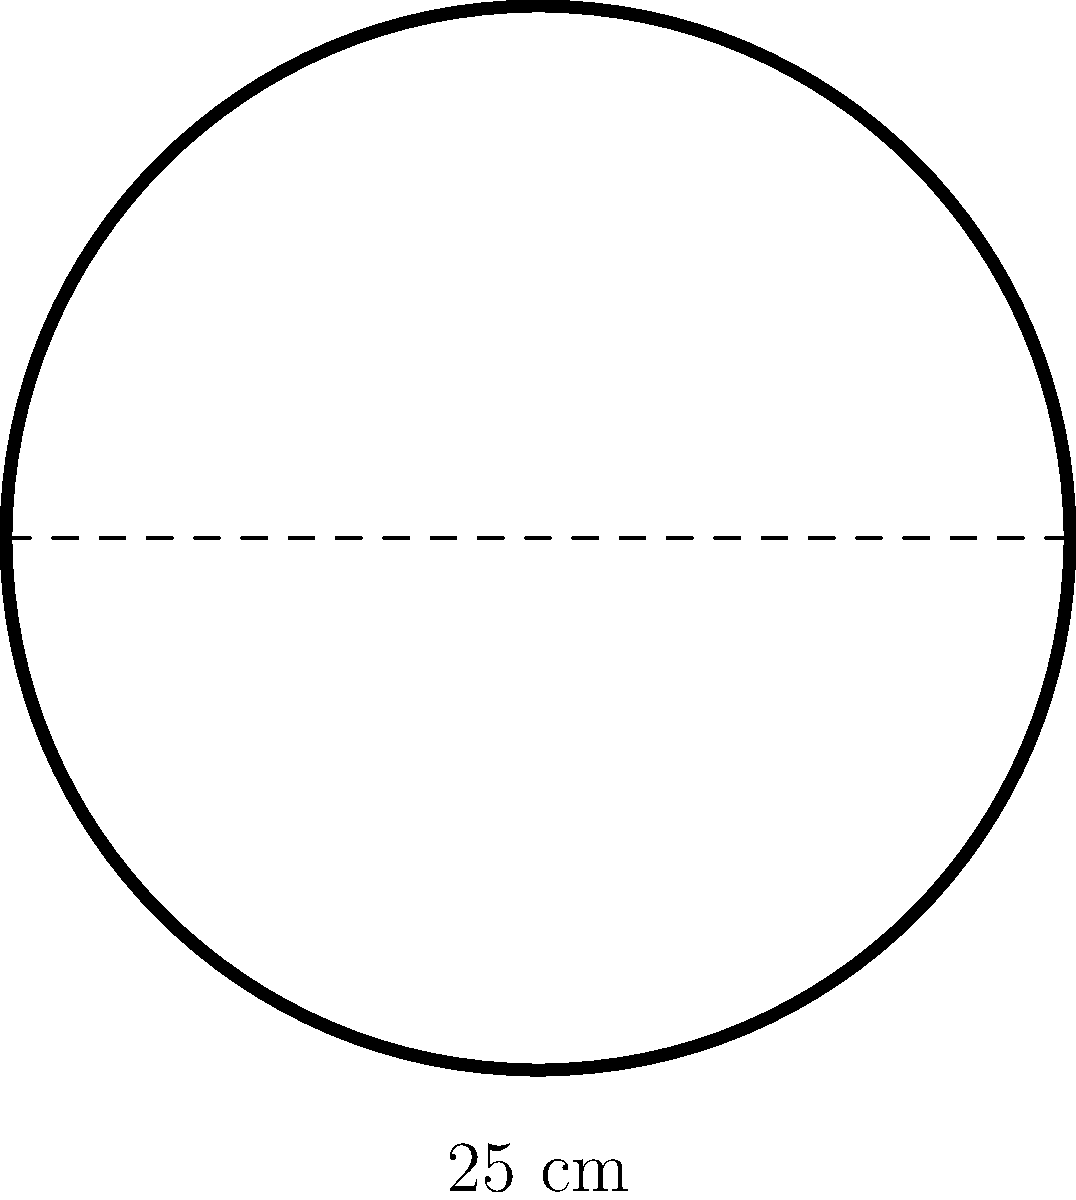As a professional weightlifter, you often work with various weight plates. You come across a circular weight plate with a diameter of 25 cm. What is the area of this weight plate in square centimeters? (Use $\pi = 3.14$ for your calculations) To find the area of a circular weight plate, we need to follow these steps:

1. Recall the formula for the area of a circle:
   $$A = \pi r^2$$
   where $A$ is the area and $r$ is the radius.

2. We are given the diameter, which is 25 cm. The radius is half of the diameter:
   $$r = \frac{25}{2} = 12.5 \text{ cm}$$

3. Now, let's substitute the values into the formula:
   $$A = \pi (12.5)^2$$

4. Calculate the square of the radius:
   $$A = \pi (156.25)$$

5. Multiply by $\pi$ (using 3.14):
   $$A = 3.14 \times 156.25 = 490.625 \text{ cm}^2$$

6. Round to two decimal places:
   $$A \approx 490.63 \text{ cm}^2$$
Answer: 490.63 cm² 